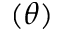<formula> <loc_0><loc_0><loc_500><loc_500>( \theta )</formula> 